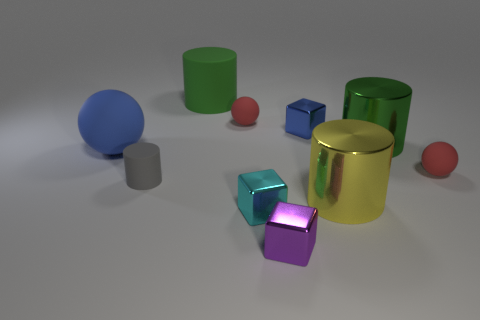What is the small blue block made of?
Ensure brevity in your answer.  Metal. There is a big yellow thing that is the same material as the purple object; what shape is it?
Your answer should be very brief. Cylinder. What number of other objects are there of the same shape as the cyan thing?
Give a very brief answer. 2. There is a gray matte cylinder; what number of purple shiny cubes are in front of it?
Give a very brief answer. 1. There is a sphere to the right of the cyan metal object; does it have the same size as the metal block that is behind the yellow object?
Ensure brevity in your answer.  Yes. How many other objects are there of the same size as the green rubber cylinder?
Your response must be concise. 3. What is the material of the block behind the small gray object that is in front of the rubber sphere that is on the left side of the gray rubber cylinder?
Your response must be concise. Metal. Does the blue shiny block have the same size as the block that is to the left of the purple thing?
Provide a succinct answer. Yes. How big is the shiny object that is both behind the tiny cyan metallic cube and in front of the tiny cylinder?
Your response must be concise. Large. Is there another cylinder of the same color as the big matte cylinder?
Offer a very short reply. Yes. 